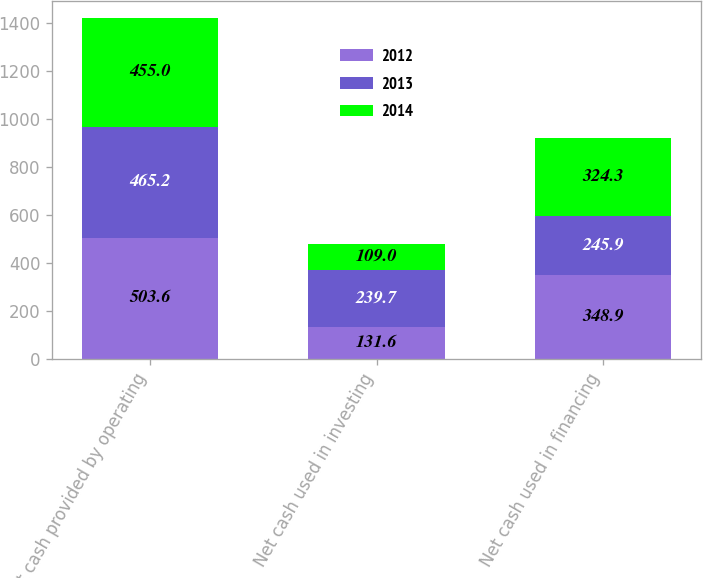Convert chart. <chart><loc_0><loc_0><loc_500><loc_500><stacked_bar_chart><ecel><fcel>Net cash provided by operating<fcel>Net cash used in investing<fcel>Net cash used in financing<nl><fcel>2012<fcel>503.6<fcel>131.6<fcel>348.9<nl><fcel>2013<fcel>465.2<fcel>239.7<fcel>245.9<nl><fcel>2014<fcel>455<fcel>109<fcel>324.3<nl></chart> 